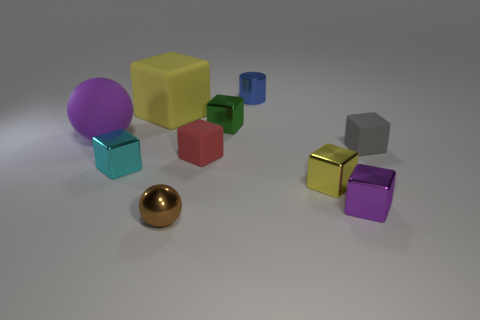Subtract all green balls. How many yellow cubes are left? 2 Subtract all small yellow shiny blocks. How many blocks are left? 6 Subtract all yellow cubes. How many cubes are left? 5 Subtract all cylinders. How many objects are left? 9 Subtract all red blocks. Subtract all red cylinders. How many blocks are left? 6 Subtract all large yellow cubes. Subtract all small gray matte cubes. How many objects are left? 8 Add 4 tiny spheres. How many tiny spheres are left? 5 Add 4 small blue cylinders. How many small blue cylinders exist? 5 Subtract 0 green balls. How many objects are left? 10 